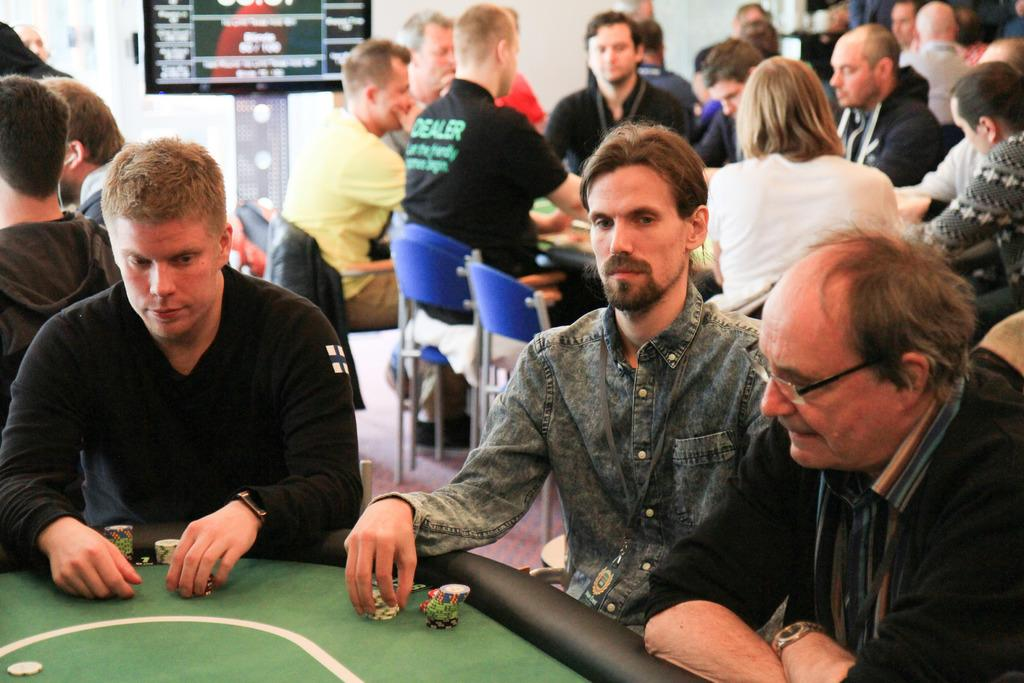What is the main object in the image? There is a board in the image. What are the people in the image doing? The people in the image are sitting on chairs. What other furniture is present in the image? There are tables in the image. What type of cheese is being used as a punishment for the people sitting on chairs in the image? There is no cheese or punishment present in the image; it only shows a board, people sitting on chairs, and tables. 